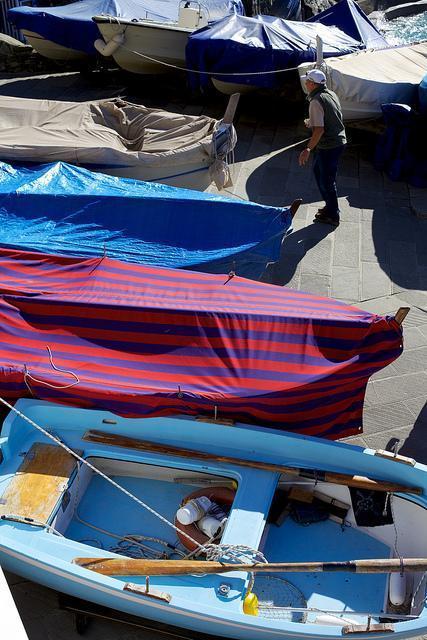How many boats is there?
Give a very brief answer. 6. How many boats are there?
Give a very brief answer. 8. 